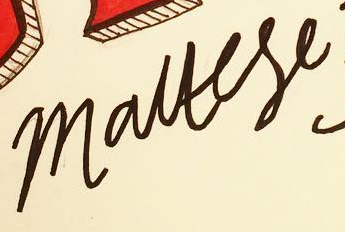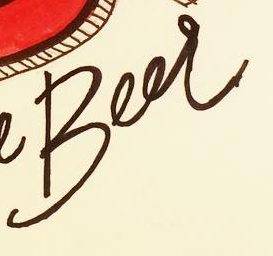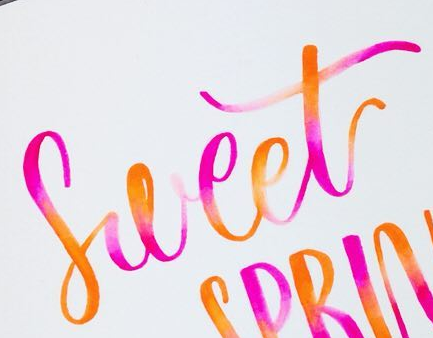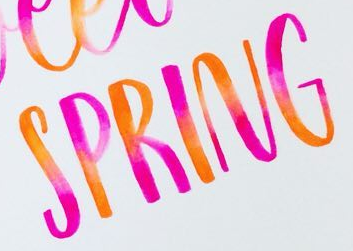Identify the words shown in these images in order, separated by a semicolon. mauese; Beer; Sweet; SPRING 